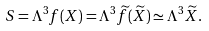<formula> <loc_0><loc_0><loc_500><loc_500>S = \Lambda ^ { 3 } f ( X ) = \Lambda ^ { 3 } \widetilde { f } ( \widetilde { X } ) \simeq \Lambda ^ { 3 } \widetilde { X } .</formula> 